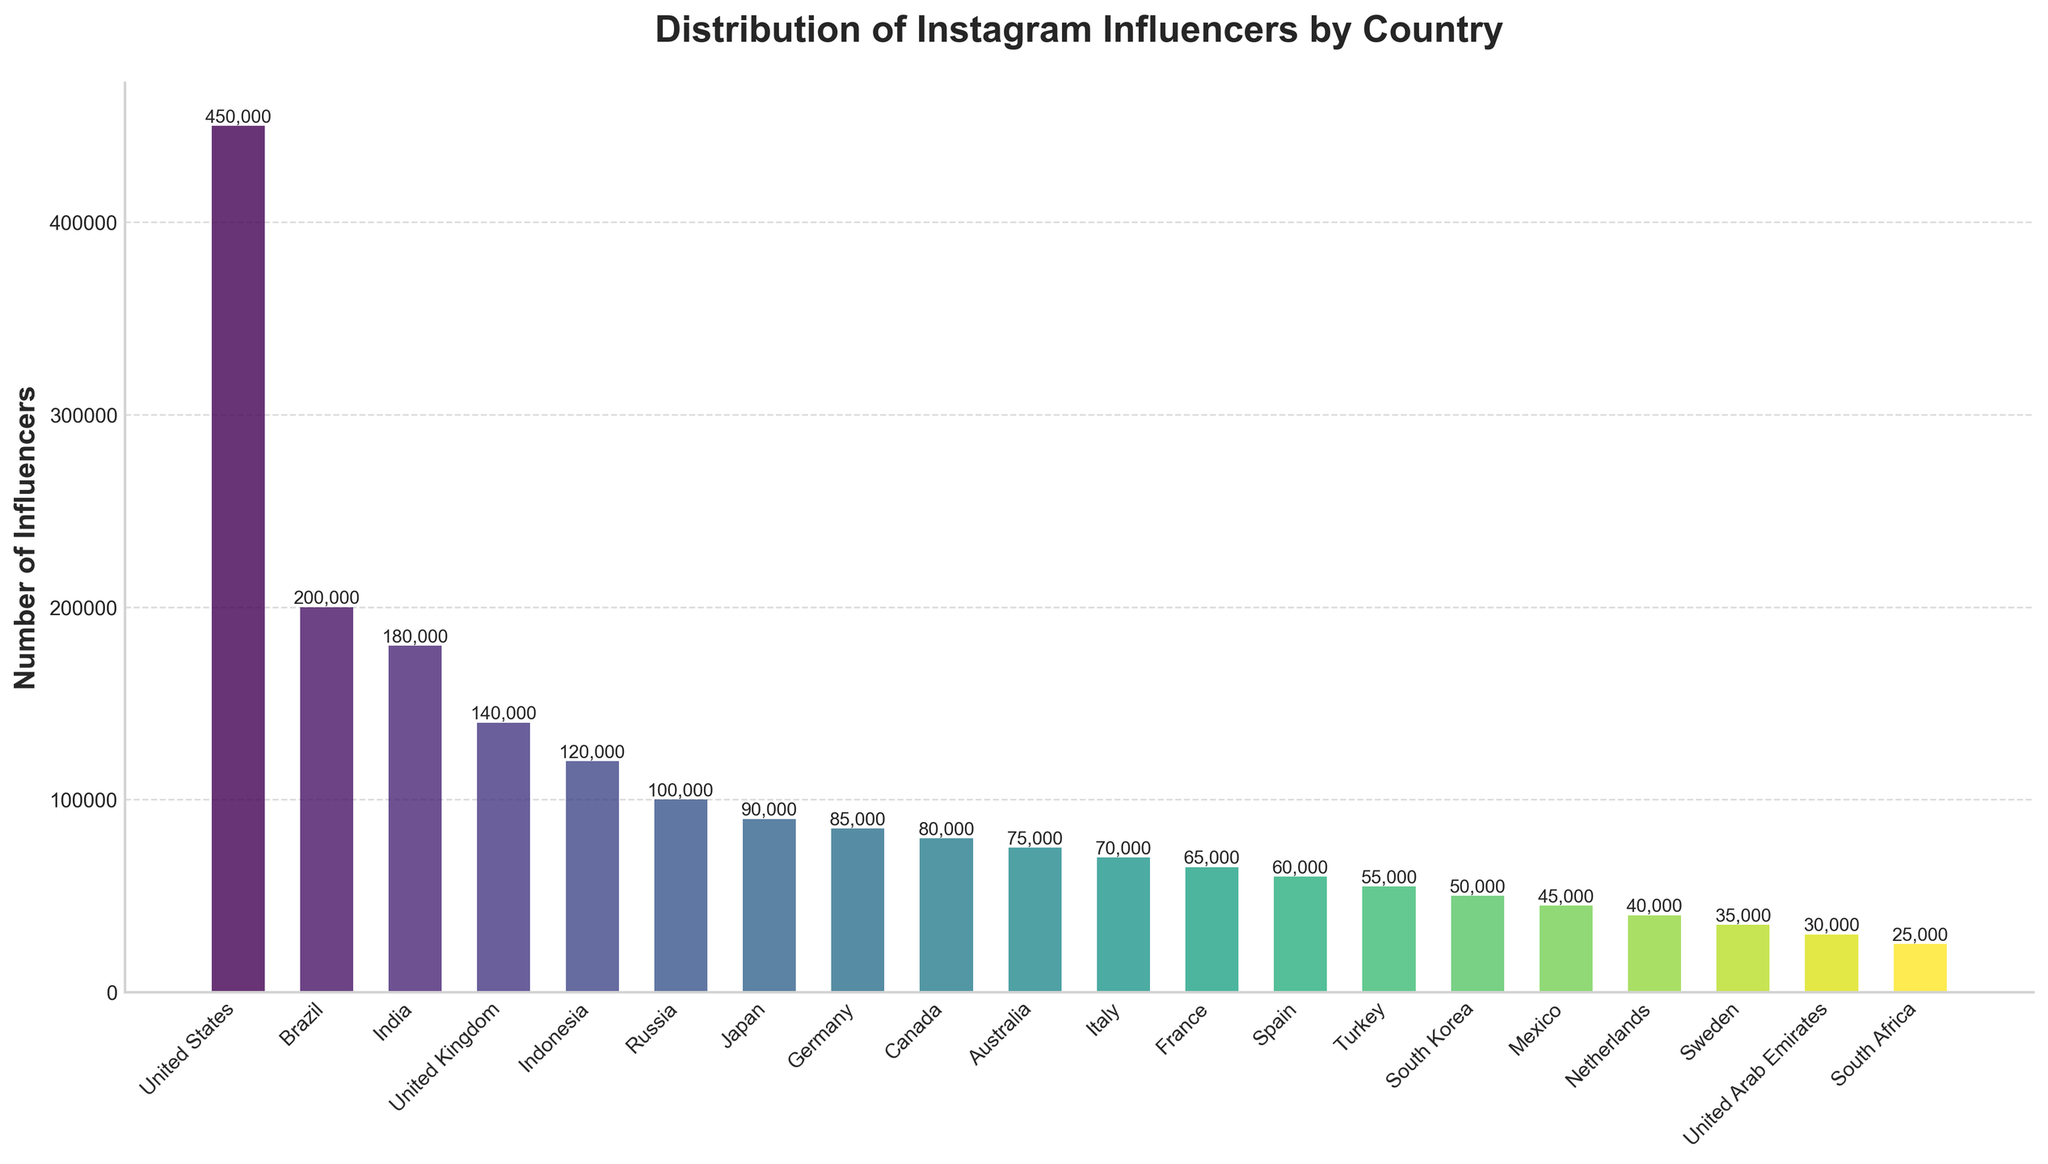What country has the highest number of Instagram influencers? The tallest bar in the bar chart represents the country with the highest number of Instagram influencers. The United States has the highest bar.
Answer: United States Which two countries have a similar number of influencers, and how many do they have? Look for bars with nearly the same height. Germany (85,000) and Canada (80,000) have similar numbers.
Answer: Germany and Canada, 85,000 and 80,000 How many more Instagram influencers are there in Brazil compared to France? Subtract the number of influencers in France from the number in Brazil: 200,000 (Brazil) - 65,000 (France).
Answer: 135,000 What is the total number of Instagram influencers in the top three countries? Add the number of influencers from the top three countries: 450,000 (United States) + 200,000 (Brazil) + 180,000 (India).
Answer: 830,000 Which country has the fewest influencers, and what is the number? The shortest bar represents the country with the fewest influencers. South Africa has the fewest with 25,000 influencers.
Answer: South Africa, 25,000 Which countries have fewer than 60,000 influencers? Identify the bars shorter than the one representing 60,000 influencers. Turkey (55,000), South Korea (50,000), Mexico (45,000), Netherlands (40,000), Sweden (35,000), UAE (30,000), and South Africa (25,000) have fewer than 60,000 influencers.
Answer: Turkey, South Korea, Mexico, Netherlands, Sweden, UAE, South Africa Are there more influencers in Japan or South Korea, and by how much? Compare the bar heights for Japan and South Korea. Japan has 90,000 influencers, South Korea has 50,000. Subtract to find the difference: 90,000 - 50,000.
Answer: Japan, 40,000 What is the average number of influencers among the countries listed? Sum the number of influencers and divide by the number of countries: (450,000 + 200,000 + 180,000 + 140,000 + 120,000 + 100,000 + 90,000 + 85,000 + 80,000 + 75,000 + 70,000 + 65,000 + 60,000 + 55,000 + 50,000 + 45,000 + 40,000 + 35,000 + 30,000 + 25,000) / 20.
Answer: 91,750 